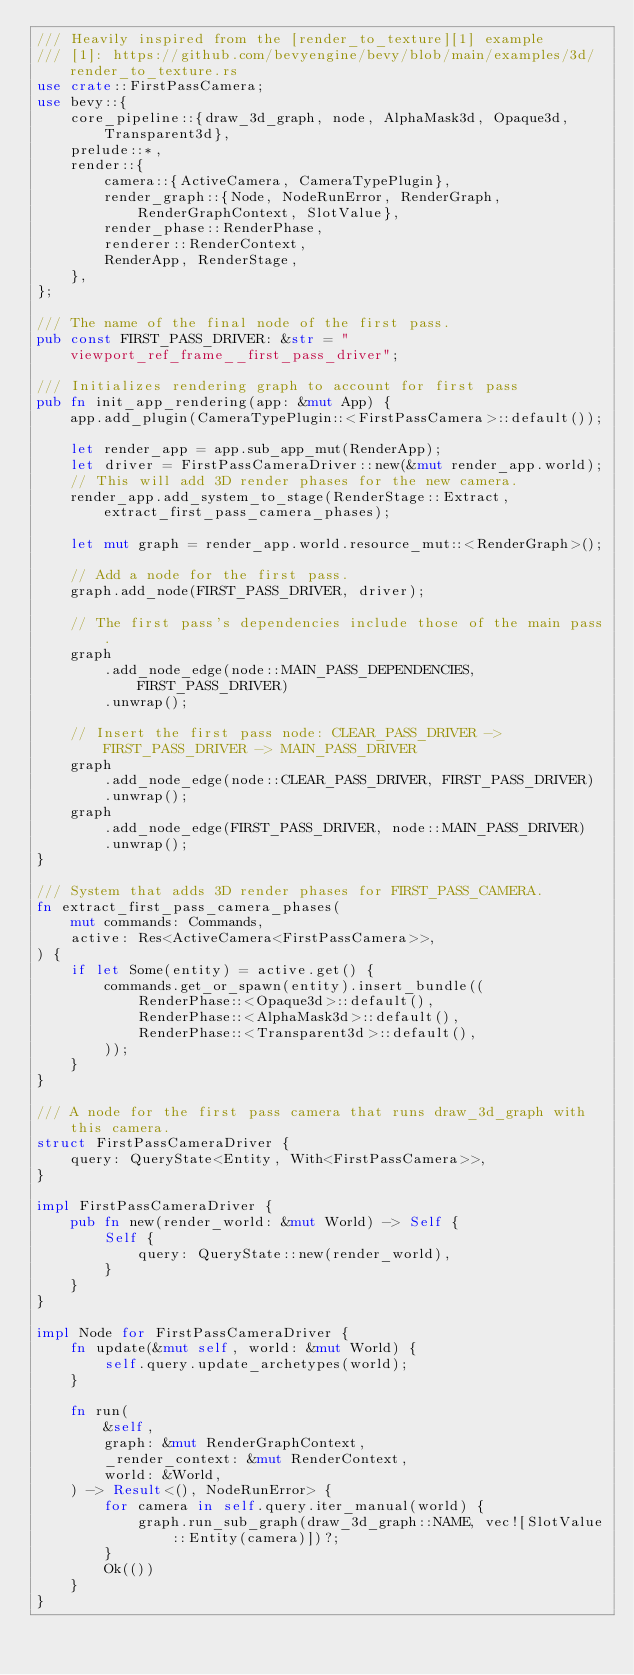<code> <loc_0><loc_0><loc_500><loc_500><_Rust_>/// Heavily inspired from the [render_to_texture][1] example
/// [1]: https://github.com/bevyengine/bevy/blob/main/examples/3d/render_to_texture.rs
use crate::FirstPassCamera;
use bevy::{
    core_pipeline::{draw_3d_graph, node, AlphaMask3d, Opaque3d, Transparent3d},
    prelude::*,
    render::{
        camera::{ActiveCamera, CameraTypePlugin},
        render_graph::{Node, NodeRunError, RenderGraph, RenderGraphContext, SlotValue},
        render_phase::RenderPhase,
        renderer::RenderContext,
        RenderApp, RenderStage,
    },
};

/// The name of the final node of the first pass.
pub const FIRST_PASS_DRIVER: &str = "viewport_ref_frame__first_pass_driver";

/// Initializes rendering graph to account for first pass
pub fn init_app_rendering(app: &mut App) {
    app.add_plugin(CameraTypePlugin::<FirstPassCamera>::default());

    let render_app = app.sub_app_mut(RenderApp);
    let driver = FirstPassCameraDriver::new(&mut render_app.world);
    // This will add 3D render phases for the new camera.
    render_app.add_system_to_stage(RenderStage::Extract, extract_first_pass_camera_phases);

    let mut graph = render_app.world.resource_mut::<RenderGraph>();

    // Add a node for the first pass.
    graph.add_node(FIRST_PASS_DRIVER, driver);

    // The first pass's dependencies include those of the main pass.
    graph
        .add_node_edge(node::MAIN_PASS_DEPENDENCIES, FIRST_PASS_DRIVER)
        .unwrap();

    // Insert the first pass node: CLEAR_PASS_DRIVER -> FIRST_PASS_DRIVER -> MAIN_PASS_DRIVER
    graph
        .add_node_edge(node::CLEAR_PASS_DRIVER, FIRST_PASS_DRIVER)
        .unwrap();
    graph
        .add_node_edge(FIRST_PASS_DRIVER, node::MAIN_PASS_DRIVER)
        .unwrap();
}

/// System that adds 3D render phases for FIRST_PASS_CAMERA.
fn extract_first_pass_camera_phases(
    mut commands: Commands,
    active: Res<ActiveCamera<FirstPassCamera>>,
) {
    if let Some(entity) = active.get() {
        commands.get_or_spawn(entity).insert_bundle((
            RenderPhase::<Opaque3d>::default(),
            RenderPhase::<AlphaMask3d>::default(),
            RenderPhase::<Transparent3d>::default(),
        ));
    }
}

/// A node for the first pass camera that runs draw_3d_graph with this camera.
struct FirstPassCameraDriver {
    query: QueryState<Entity, With<FirstPassCamera>>,
}

impl FirstPassCameraDriver {
    pub fn new(render_world: &mut World) -> Self {
        Self {
            query: QueryState::new(render_world),
        }
    }
}

impl Node for FirstPassCameraDriver {
    fn update(&mut self, world: &mut World) {
        self.query.update_archetypes(world);
    }

    fn run(
        &self,
        graph: &mut RenderGraphContext,
        _render_context: &mut RenderContext,
        world: &World,
    ) -> Result<(), NodeRunError> {
        for camera in self.query.iter_manual(world) {
            graph.run_sub_graph(draw_3d_graph::NAME, vec![SlotValue::Entity(camera)])?;
        }
        Ok(())
    }
}
</code> 